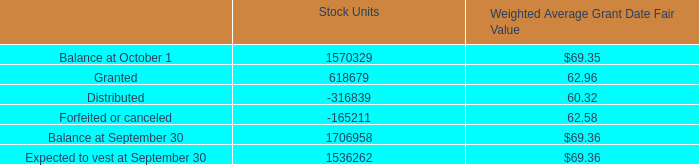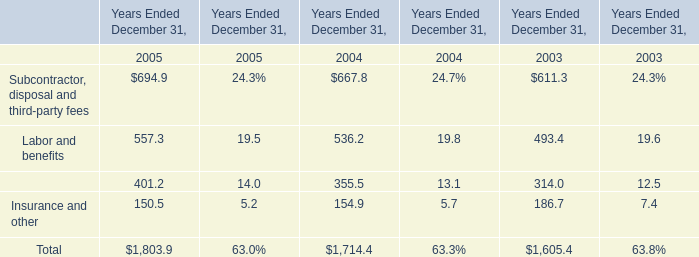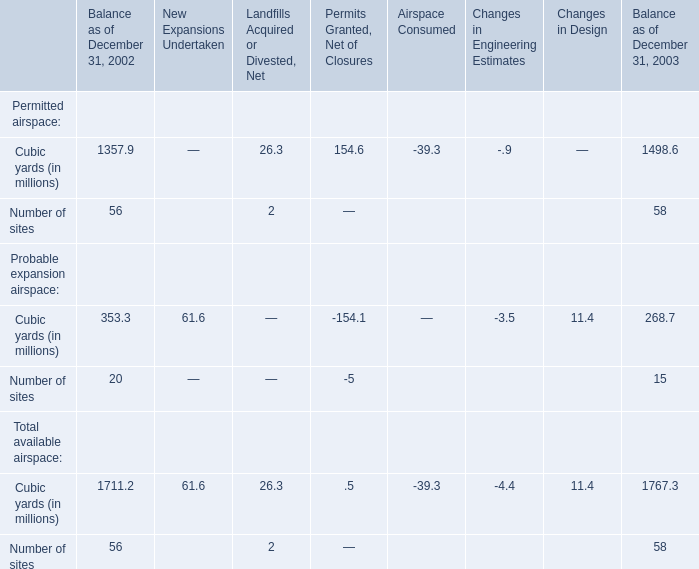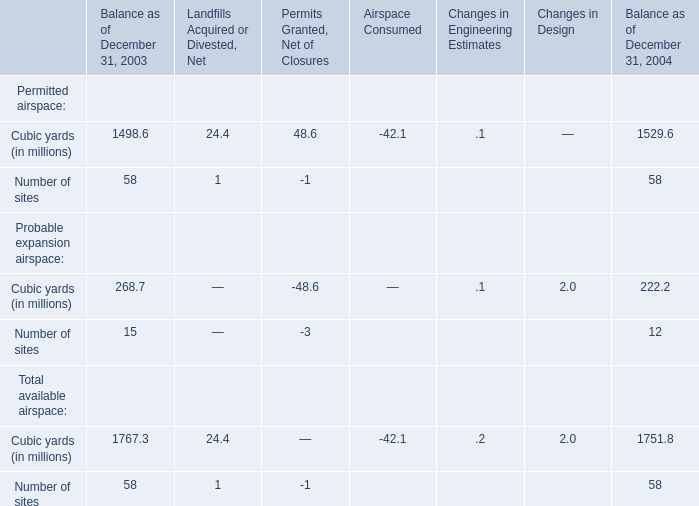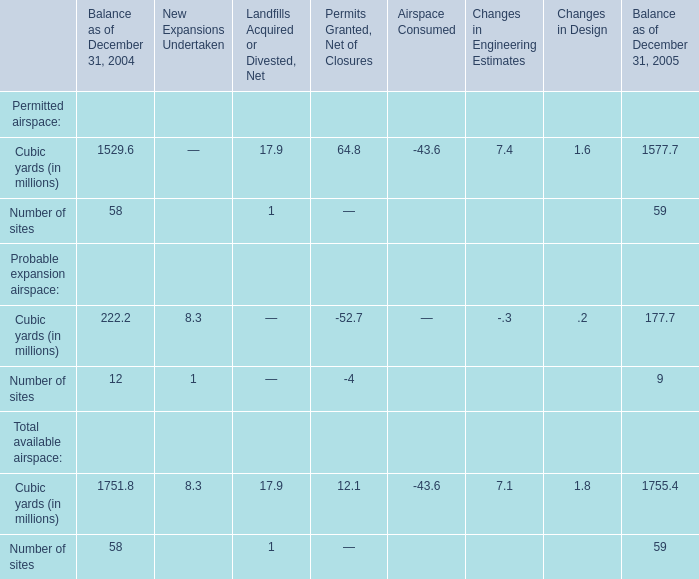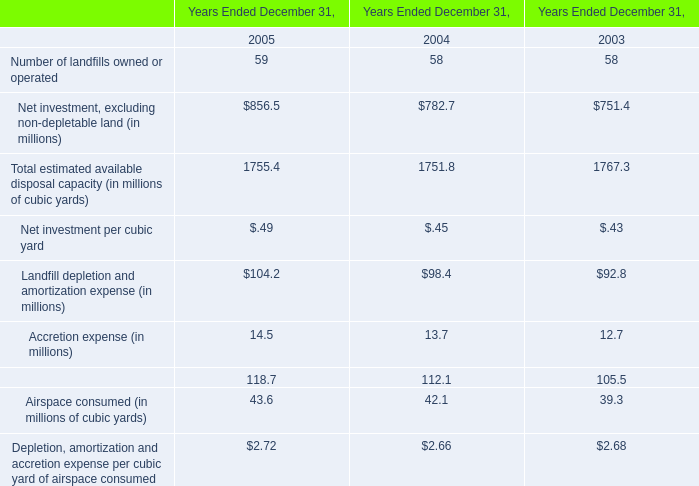As As the chart 3 shows,Balance as of December 31, which year for Cubic yards in terms of Total available airspace ranks first? 
Answer: 2003. 